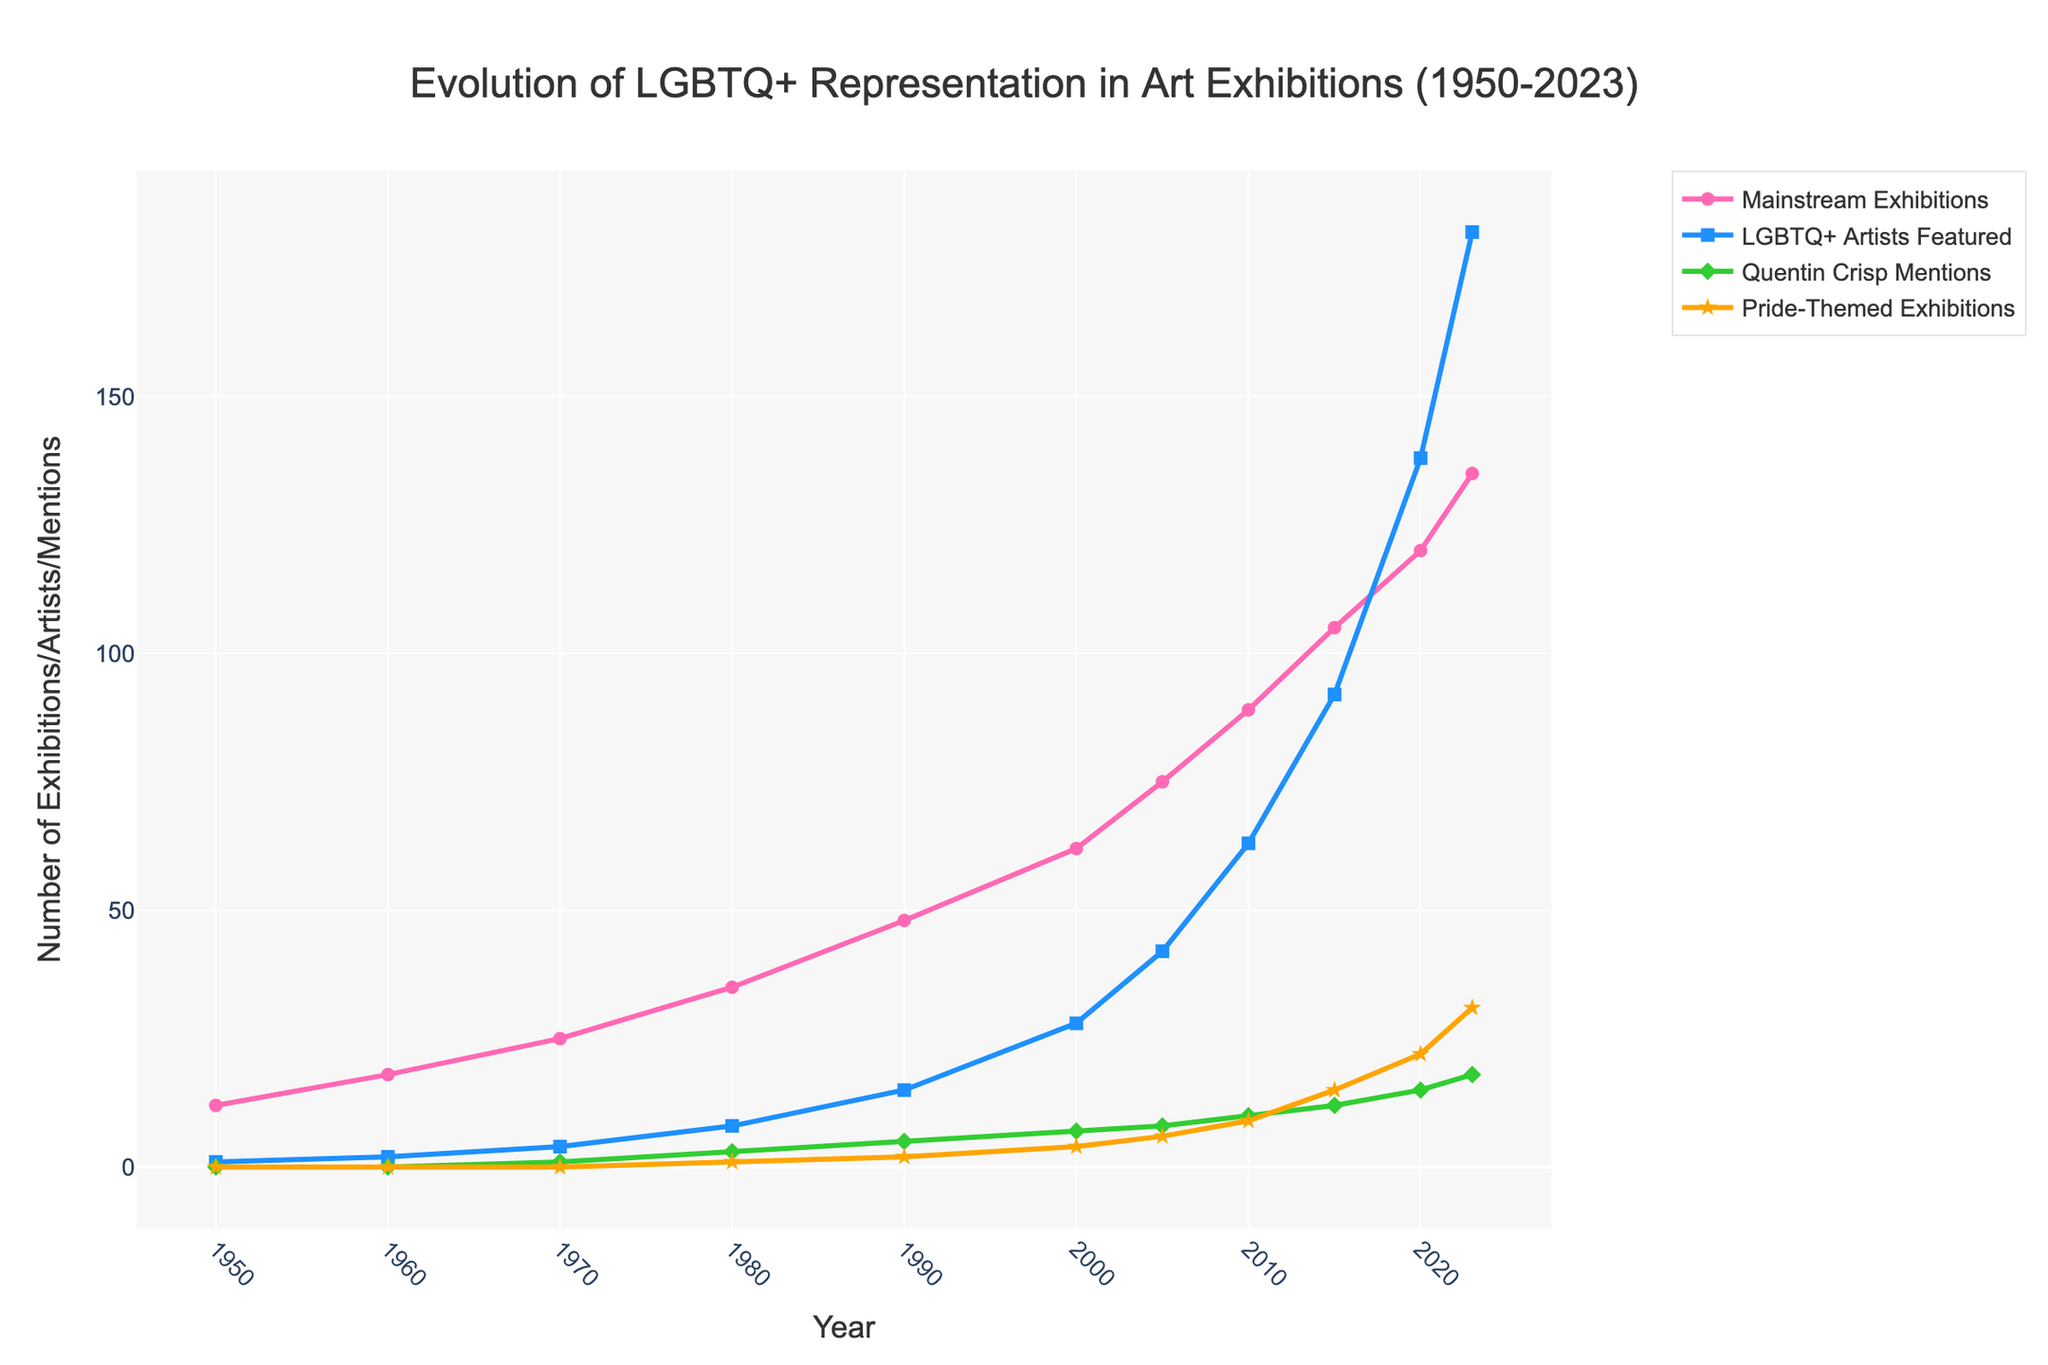How many LGBTQ+ artists were featured in mainstream exhibitions in 1980? Identify the value of the "LGBTQ+ Artists Featured" line for 1980. The number is indicated as 8 in the data.
Answer: 8 Which year saw the highest number of Pride-Themed Exhibitions? Locate the peak of the "Pride-Themed Exhibitions" line. It reaches its highest point in 2023 with a value of 31.
Answer: 2023 By how much did the number of Quenting Crisp mentions increase from 1970 to 2023? Subtract the number of Quentin Crisp mentions for 1970 (1 mention) from the number in 2023 (18 mentions). The difference is 18 - 1 = 17.
Answer: 17 Compare the number of mainstream exhibitions in 2000 to those in 2010. Which year had more, and by how many? Compare the values of the "Mainstream Exhibitions" line for 2000 and 2010. The values are 62 for 2000 and 89 for 2010. The difference is 89 - 62 = 27.
Answer: 2010, by 27 What is the overall trend of LGBTQ+ representation in mainstream art exhibitions from 1950 to 2023? Observe the trend lines for both "Mainstream Exhibitions" and "LGBTQ+ Artists Featured." Both lines show a steadily increasing trend from 1950 to 2023, indicating rising LGBTQ+ representation.
Answer: Increasing How many more LGBTQ+ artists were featured in mainstream exhibitions in 2020 compared to 2000? Subtract the number of "LGBTQ+ Artists Featured" in 2000 (28) from the number in 2020 (138). The difference is 138 - 28 = 110
Answer: 110 In which decade did the number of mainstream exhibitions featuring LGBTQ+ artists first exceed 100? Identify the first year on the "Mainstream Exhibitions" line that exceeds 100. It occurs in 2015.
Answer: 2015 If we average the Pride-Themed Exhibitions from 1950 to 2023, what is the approximate number? Add the number of "Pride-Themed Exhibitions" for all years, which is 0+0+0+1+2+4+6+9+15+22+31 = 90, and divide by the count of years, which is 11. This gives an average of 90 / 11 ≈ 8.18.
Answer: Approximately 8.18 